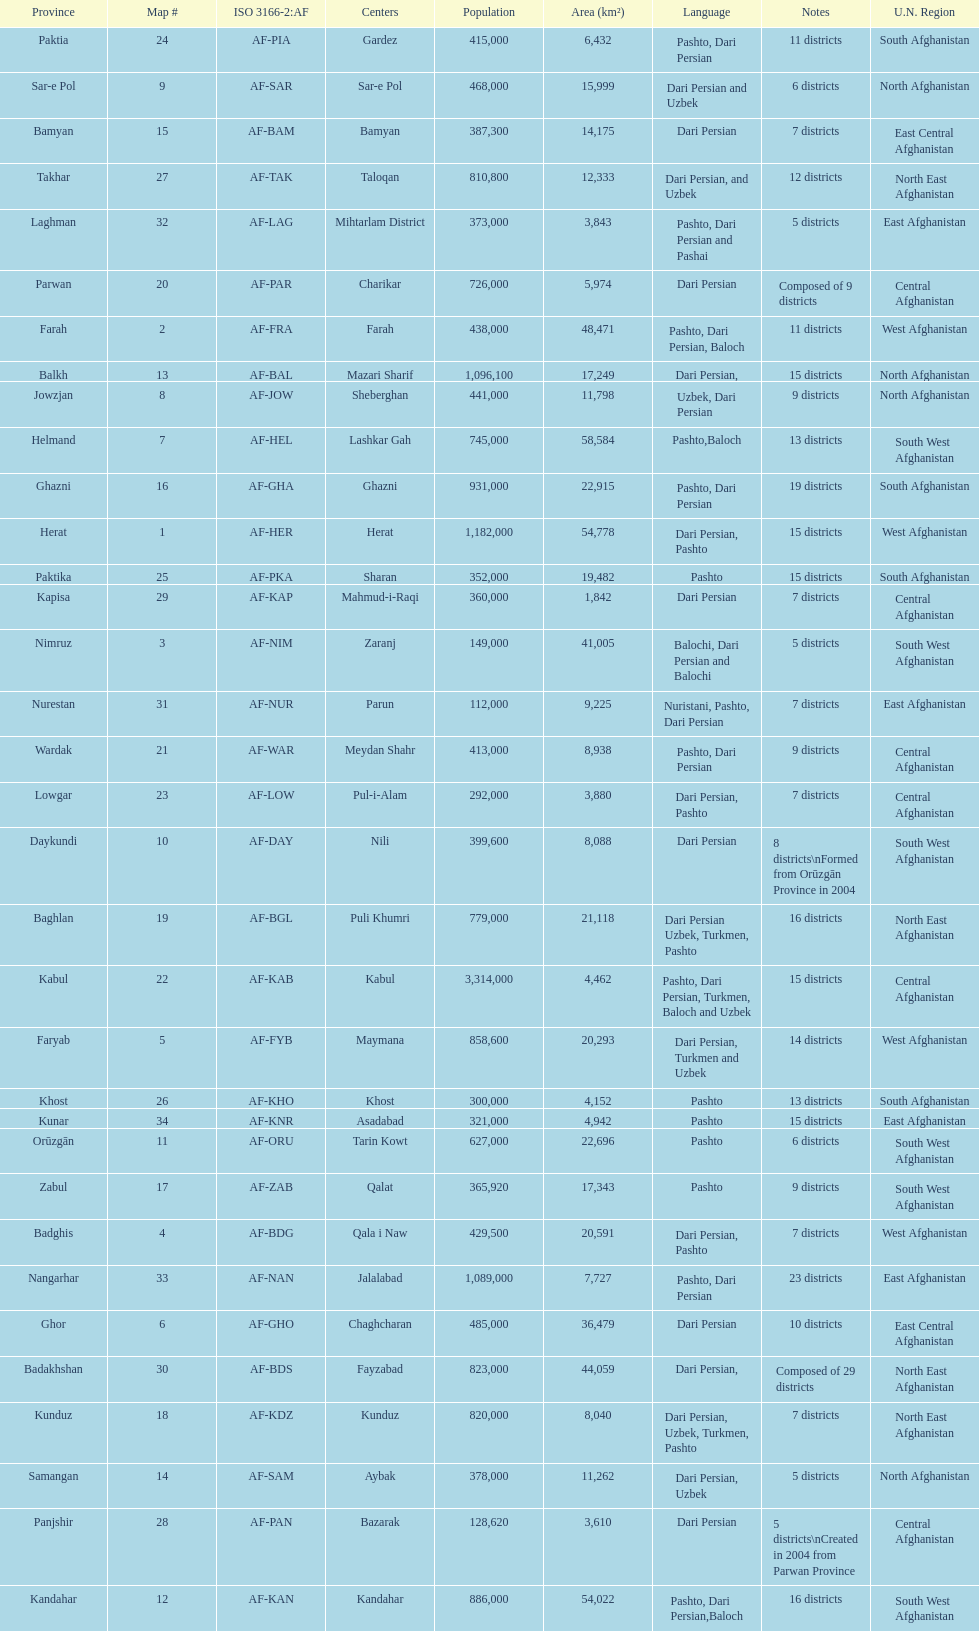Would you mind parsing the complete table? {'header': ['Province', 'Map #', 'ISO 3166-2:AF', 'Centers', 'Population', 'Area (km²)', 'Language', 'Notes', 'U.N. Region'], 'rows': [['Paktia', '24', 'AF-PIA', 'Gardez', '415,000', '6,432', 'Pashto, Dari Persian', '11 districts', 'South Afghanistan'], ['Sar-e Pol', '9', 'AF-SAR', 'Sar-e Pol', '468,000', '15,999', 'Dari Persian and Uzbek', '6 districts', 'North Afghanistan'], ['Bamyan', '15', 'AF-BAM', 'Bamyan', '387,300', '14,175', 'Dari Persian', '7 districts', 'East Central Afghanistan'], ['Takhar', '27', 'AF-TAK', 'Taloqan', '810,800', '12,333', 'Dari Persian, and Uzbek', '12 districts', 'North East Afghanistan'], ['Laghman', '32', 'AF-LAG', 'Mihtarlam District', '373,000', '3,843', 'Pashto, Dari Persian and Pashai', '5 districts', 'East Afghanistan'], ['Parwan', '20', 'AF-PAR', 'Charikar', '726,000', '5,974', 'Dari Persian', 'Composed of 9 districts', 'Central Afghanistan'], ['Farah', '2', 'AF-FRA', 'Farah', '438,000', '48,471', 'Pashto, Dari Persian, Baloch', '11 districts', 'West Afghanistan'], ['Balkh', '13', 'AF-BAL', 'Mazari Sharif', '1,096,100', '17,249', 'Dari Persian,', '15 districts', 'North Afghanistan'], ['Jowzjan', '8', 'AF-JOW', 'Sheberghan', '441,000', '11,798', 'Uzbek, Dari Persian', '9 districts', 'North Afghanistan'], ['Helmand', '7', 'AF-HEL', 'Lashkar Gah', '745,000', '58,584', 'Pashto,Baloch', '13 districts', 'South West Afghanistan'], ['Ghazni', '16', 'AF-GHA', 'Ghazni', '931,000', '22,915', 'Pashto, Dari Persian', '19 districts', 'South Afghanistan'], ['Herat', '1', 'AF-HER', 'Herat', '1,182,000', '54,778', 'Dari Persian, Pashto', '15 districts', 'West Afghanistan'], ['Paktika', '25', 'AF-PKA', 'Sharan', '352,000', '19,482', 'Pashto', '15 districts', 'South Afghanistan'], ['Kapisa', '29', 'AF-KAP', 'Mahmud-i-Raqi', '360,000', '1,842', 'Dari Persian', '7 districts', 'Central Afghanistan'], ['Nimruz', '3', 'AF-NIM', 'Zaranj', '149,000', '41,005', 'Balochi, Dari Persian and Balochi', '5 districts', 'South West Afghanistan'], ['Nurestan', '31', 'AF-NUR', 'Parun', '112,000', '9,225', 'Nuristani, Pashto, Dari Persian', '7 districts', 'East Afghanistan'], ['Wardak', '21', 'AF-WAR', 'Meydan Shahr', '413,000', '8,938', 'Pashto, Dari Persian', '9 districts', 'Central Afghanistan'], ['Lowgar', '23', 'AF-LOW', 'Pul-i-Alam', '292,000', '3,880', 'Dari Persian, Pashto', '7 districts', 'Central Afghanistan'], ['Daykundi', '10', 'AF-DAY', 'Nili', '399,600', '8,088', 'Dari Persian', '8 districts\\nFormed from Orūzgān Province in 2004', 'South West Afghanistan'], ['Baghlan', '19', 'AF-BGL', 'Puli Khumri', '779,000', '21,118', 'Dari Persian Uzbek, Turkmen, Pashto', '16 districts', 'North East Afghanistan'], ['Kabul', '22', 'AF-KAB', 'Kabul', '3,314,000', '4,462', 'Pashto, Dari Persian, Turkmen, Baloch and Uzbek', '15 districts', 'Central Afghanistan'], ['Faryab', '5', 'AF-FYB', 'Maymana', '858,600', '20,293', 'Dari Persian, Turkmen and Uzbek', '14 districts', 'West Afghanistan'], ['Khost', '26', 'AF-KHO', 'Khost', '300,000', '4,152', 'Pashto', '13 districts', 'South Afghanistan'], ['Kunar', '34', 'AF-KNR', 'Asadabad', '321,000', '4,942', 'Pashto', '15 districts', 'East Afghanistan'], ['Orūzgān', '11', 'AF-ORU', 'Tarin Kowt', '627,000', '22,696', 'Pashto', '6 districts', 'South West Afghanistan'], ['Zabul', '17', 'AF-ZAB', 'Qalat', '365,920', '17,343', 'Pashto', '9 districts', 'South West Afghanistan'], ['Badghis', '4', 'AF-BDG', 'Qala i Naw', '429,500', '20,591', 'Dari Persian, Pashto', '7 districts', 'West Afghanistan'], ['Nangarhar', '33', 'AF-NAN', 'Jalalabad', '1,089,000', '7,727', 'Pashto, Dari Persian', '23 districts', 'East Afghanistan'], ['Ghor', '6', 'AF-GHO', 'Chaghcharan', '485,000', '36,479', 'Dari Persian', '10 districts', 'East Central Afghanistan'], ['Badakhshan', '30', 'AF-BDS', 'Fayzabad', '823,000', '44,059', 'Dari Persian,', 'Composed of 29 districts', 'North East Afghanistan'], ['Kunduz', '18', 'AF-KDZ', 'Kunduz', '820,000', '8,040', 'Dari Persian, Uzbek, Turkmen, Pashto', '7 districts', 'North East Afghanistan'], ['Samangan', '14', 'AF-SAM', 'Aybak', '378,000', '11,262', 'Dari Persian, Uzbek', '5 districts', 'North Afghanistan'], ['Panjshir', '28', 'AF-PAN', 'Bazarak', '128,620', '3,610', 'Dari Persian', '5 districts\\nCreated in 2004 from Parwan Province', 'Central Afghanistan'], ['Kandahar', '12', 'AF-KAN', 'Kandahar', '886,000', '54,022', 'Pashto, Dari Persian,Baloch', '16 districts', 'South West Afghanistan']]} How many districts are in the province of kunduz? 7. 